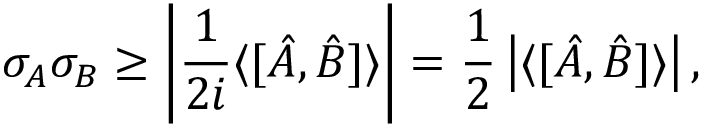<formula> <loc_0><loc_0><loc_500><loc_500>\sigma _ { A } \sigma _ { B } \geq \left | { \frac { 1 } { 2 i } } \langle [ { \hat { A } } , { \hat { B } } ] \rangle \right | = { \frac { 1 } { 2 } } \left | \langle [ { \hat { A } } , { \hat { B } } ] \rangle \right | ,</formula> 